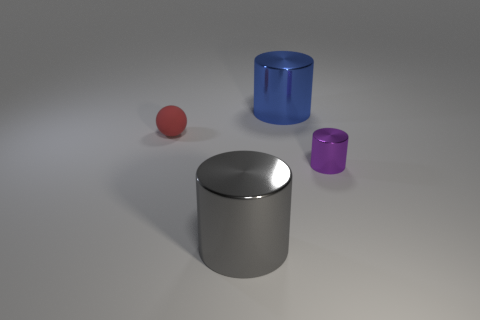Add 3 purple metal things. How many objects exist? 7 Subtract all cylinders. How many objects are left? 1 Add 1 tiny rubber spheres. How many tiny rubber spheres exist? 2 Subtract 0 gray spheres. How many objects are left? 4 Subtract all large matte spheres. Subtract all gray things. How many objects are left? 3 Add 4 big gray shiny cylinders. How many big gray shiny cylinders are left? 5 